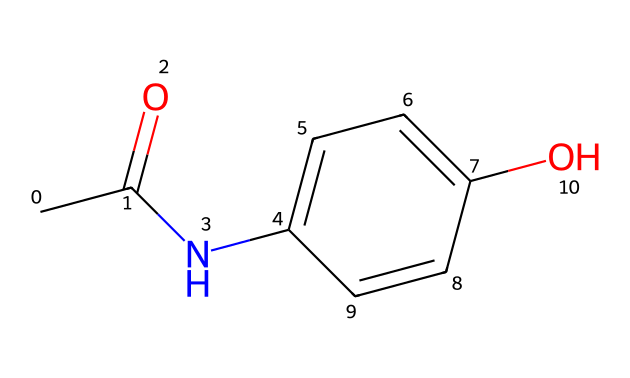What is the name of this chemical? The SMILES representation corresponds to the structure of paracetamol, which is widely recognized by its common name. The key functional groups—an amide and a phenolic hydroxyl—confirm this identification.
Answer: paracetamol How many carbon atoms are present in this molecule? By analyzing the SMILES representation, we count the carbon atoms. The structure indicates there are eight carbon atoms, as seen in both the acetyl group and the aromatic ring.
Answer: eight What type of functional group is present at the left end of the chemical? The left end showcases a carbonyl group (C=O) attached to an amine group (NH), which collectively forms an amide functional group, characteristic of paracetamol.
Answer: amide How many rings are present in this chemical? The structure displays one aromatic ring within the chemical. An aromatic ring is identified by its six-carbon configuration with alternating double bonds, characteristic of benzene derivatives.
Answer: one How many hydrogen atoms are in this molecule? To determine the total number of hydrogen atoms, we analyze the structure and apply the tetravalent nature of carbon, alongside hydrogen's role in the functional groups. This results in a total of nine hydrogen atoms.
Answer: nine Does this compound have any functional groups responsible for analgesic properties? Yes, the presence of the amide and hydroxyl groups in paracetamol is directly linked to its analgesic properties, as these groups can interact with pain receptors.
Answer: yes 